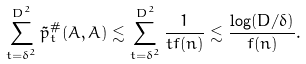Convert formula to latex. <formula><loc_0><loc_0><loc_500><loc_500>\sum _ { t = \delta ^ { 2 } } ^ { D ^ { 2 } } \tilde { p } ^ { \# } _ { t } ( A , A ) \lesssim \sum _ { t = \delta ^ { 2 } } ^ { D ^ { 2 } } \frac { 1 } { t f ( n ) } \lesssim \frac { \log ( D / \delta ) } { f ( n ) } .</formula> 